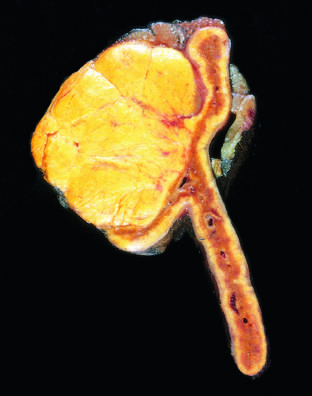s the adenoma distinguished from nodular hyperplasia by its solitary, circumscribed nature?
Answer the question using a single word or phrase. Yes 